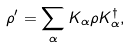<formula> <loc_0><loc_0><loc_500><loc_500>\rho ^ { \prime } = \sum _ { \alpha } K _ { \alpha } \rho K _ { \alpha } ^ { \dagger } ,</formula> 